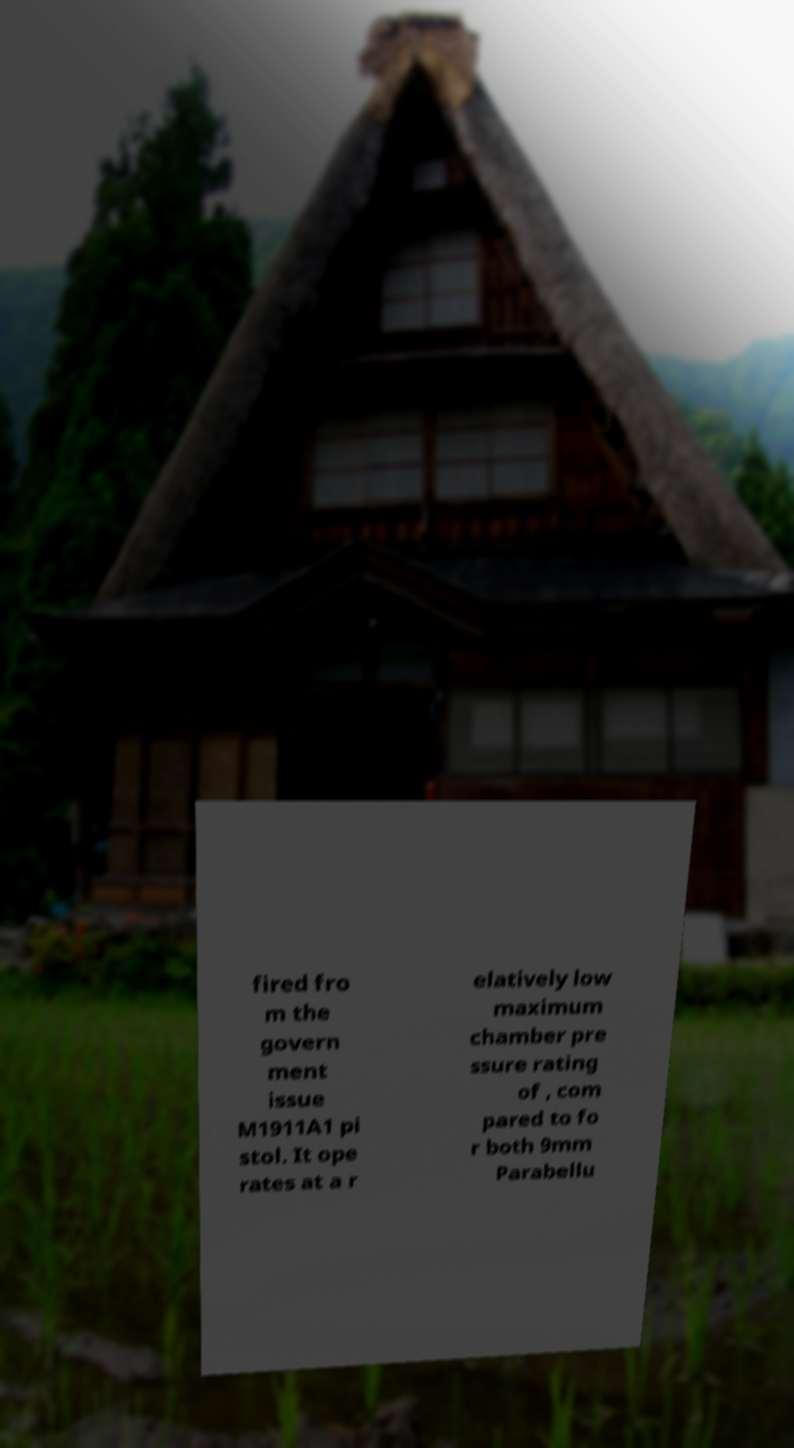Could you extract and type out the text from this image? fired fro m the govern ment issue M1911A1 pi stol. It ope rates at a r elatively low maximum chamber pre ssure rating of , com pared to fo r both 9mm Parabellu 